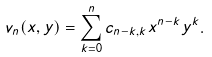Convert formula to latex. <formula><loc_0><loc_0><loc_500><loc_500>v _ { n } ( x , y ) = \sum _ { k = 0 } ^ { n } c _ { n - k , k } x ^ { n - k } y ^ { k } .</formula> 